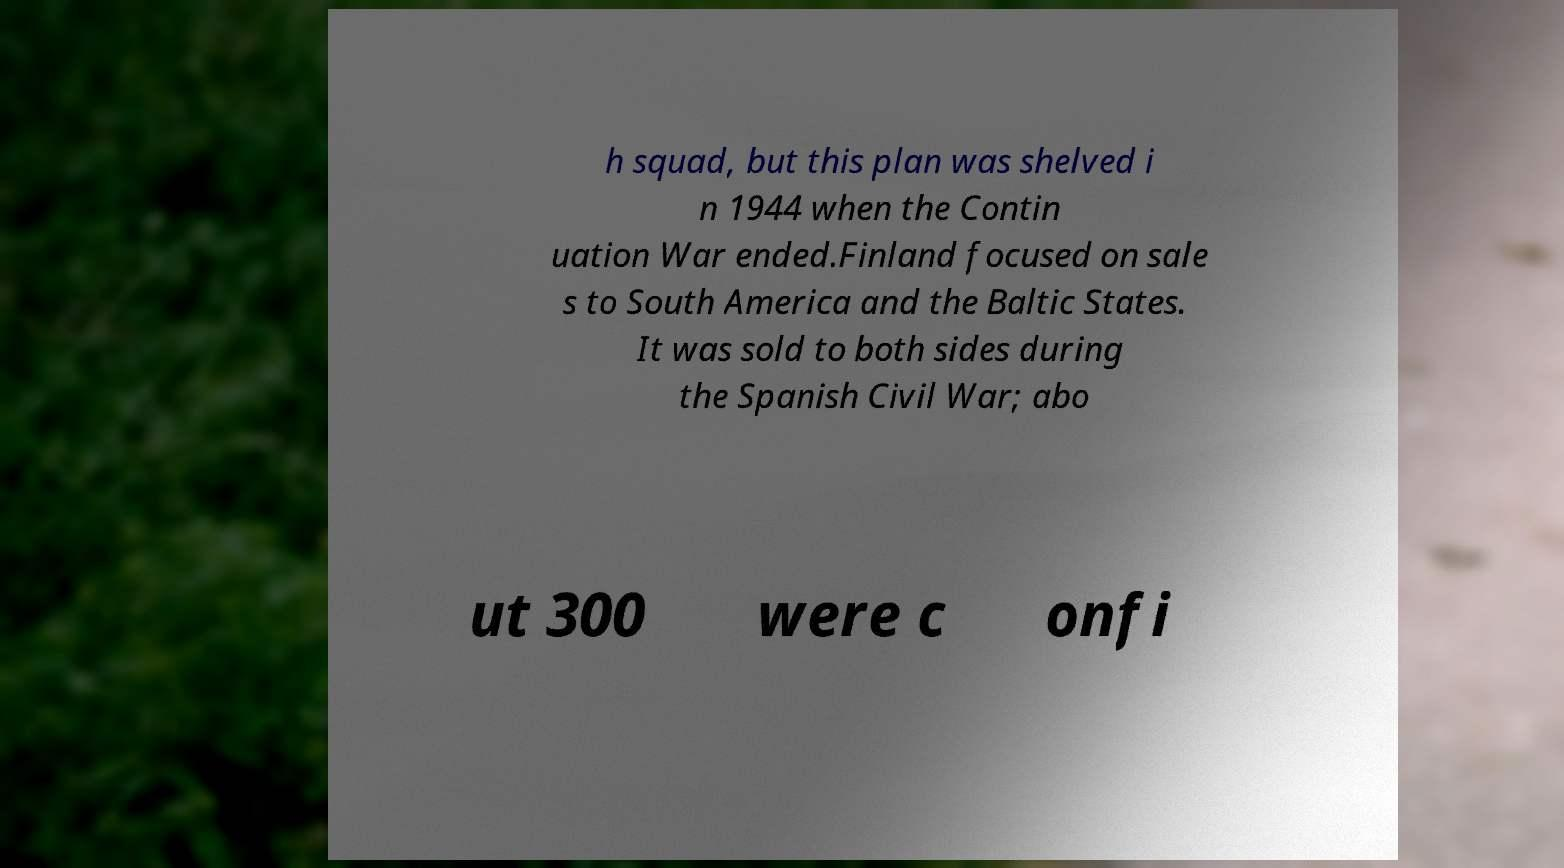What messages or text are displayed in this image? I need them in a readable, typed format. h squad, but this plan was shelved i n 1944 when the Contin uation War ended.Finland focused on sale s to South America and the Baltic States. It was sold to both sides during the Spanish Civil War; abo ut 300 were c onfi 